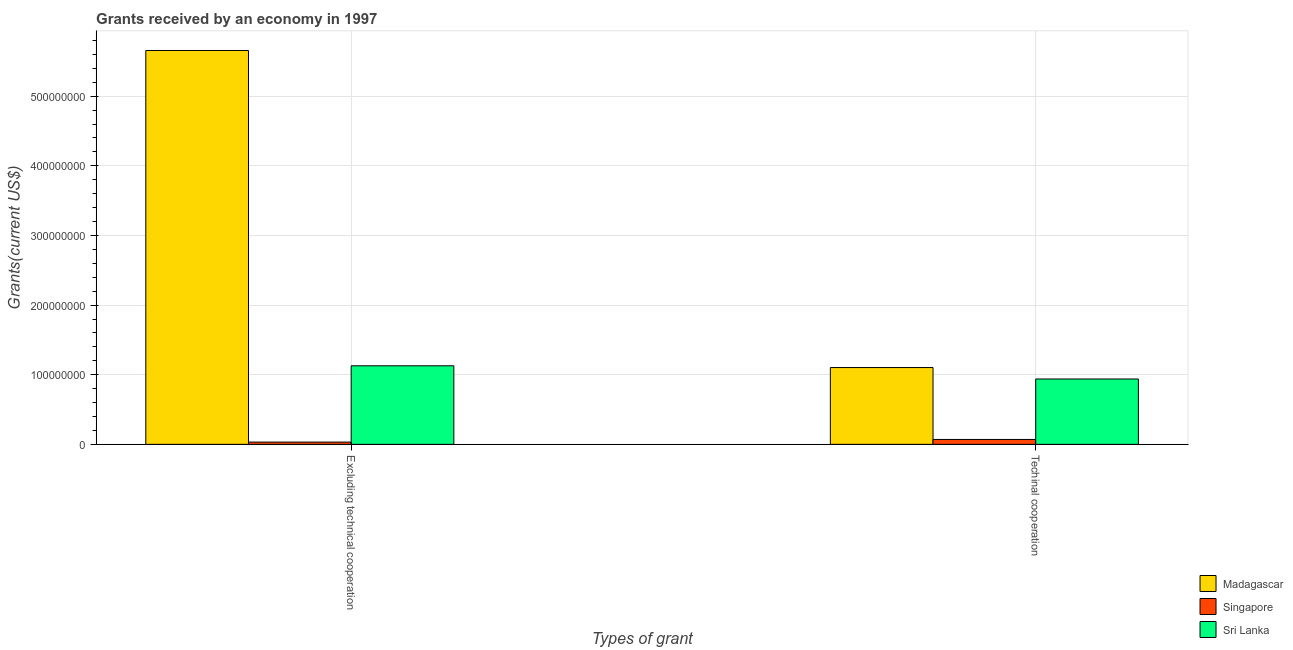Are the number of bars per tick equal to the number of legend labels?
Offer a terse response. Yes. Are the number of bars on each tick of the X-axis equal?
Offer a terse response. Yes. What is the label of the 2nd group of bars from the left?
Provide a succinct answer. Techinal cooperation. What is the amount of grants received(including technical cooperation) in Sri Lanka?
Offer a very short reply. 9.39e+07. Across all countries, what is the maximum amount of grants received(including technical cooperation)?
Your response must be concise. 1.10e+08. Across all countries, what is the minimum amount of grants received(including technical cooperation)?
Offer a terse response. 7.02e+06. In which country was the amount of grants received(excluding technical cooperation) maximum?
Provide a short and direct response. Madagascar. In which country was the amount of grants received(excluding technical cooperation) minimum?
Keep it short and to the point. Singapore. What is the total amount of grants received(including technical cooperation) in the graph?
Provide a succinct answer. 2.11e+08. What is the difference between the amount of grants received(excluding technical cooperation) in Sri Lanka and that in Madagascar?
Your answer should be very brief. -4.53e+08. What is the difference between the amount of grants received(including technical cooperation) in Sri Lanka and the amount of grants received(excluding technical cooperation) in Singapore?
Offer a very short reply. 9.06e+07. What is the average amount of grants received(including technical cooperation) per country?
Make the answer very short. 7.04e+07. What is the difference between the amount of grants received(including technical cooperation) and amount of grants received(excluding technical cooperation) in Sri Lanka?
Provide a succinct answer. -1.90e+07. What is the ratio of the amount of grants received(including technical cooperation) in Madagascar to that in Sri Lanka?
Ensure brevity in your answer.  1.17. Is the amount of grants received(including technical cooperation) in Sri Lanka less than that in Singapore?
Ensure brevity in your answer.  No. What does the 1st bar from the left in Techinal cooperation represents?
Give a very brief answer. Madagascar. What does the 1st bar from the right in Excluding technical cooperation represents?
Provide a succinct answer. Sri Lanka. How many bars are there?
Provide a short and direct response. 6. Are all the bars in the graph horizontal?
Provide a succinct answer. No. Does the graph contain grids?
Your answer should be compact. Yes. What is the title of the graph?
Ensure brevity in your answer.  Grants received by an economy in 1997. What is the label or title of the X-axis?
Provide a succinct answer. Types of grant. What is the label or title of the Y-axis?
Provide a succinct answer. Grants(current US$). What is the Grants(current US$) of Madagascar in Excluding technical cooperation?
Your answer should be compact. 5.66e+08. What is the Grants(current US$) of Singapore in Excluding technical cooperation?
Your response must be concise. 3.26e+06. What is the Grants(current US$) of Sri Lanka in Excluding technical cooperation?
Your answer should be compact. 1.13e+08. What is the Grants(current US$) in Madagascar in Techinal cooperation?
Offer a very short reply. 1.10e+08. What is the Grants(current US$) of Singapore in Techinal cooperation?
Your answer should be very brief. 7.02e+06. What is the Grants(current US$) of Sri Lanka in Techinal cooperation?
Provide a succinct answer. 9.39e+07. Across all Types of grant, what is the maximum Grants(current US$) of Madagascar?
Ensure brevity in your answer.  5.66e+08. Across all Types of grant, what is the maximum Grants(current US$) in Singapore?
Provide a succinct answer. 7.02e+06. Across all Types of grant, what is the maximum Grants(current US$) in Sri Lanka?
Provide a succinct answer. 1.13e+08. Across all Types of grant, what is the minimum Grants(current US$) in Madagascar?
Provide a short and direct response. 1.10e+08. Across all Types of grant, what is the minimum Grants(current US$) in Singapore?
Provide a succinct answer. 3.26e+06. Across all Types of grant, what is the minimum Grants(current US$) in Sri Lanka?
Ensure brevity in your answer.  9.39e+07. What is the total Grants(current US$) of Madagascar in the graph?
Offer a very short reply. 6.76e+08. What is the total Grants(current US$) of Singapore in the graph?
Give a very brief answer. 1.03e+07. What is the total Grants(current US$) in Sri Lanka in the graph?
Keep it short and to the point. 2.07e+08. What is the difference between the Grants(current US$) in Madagascar in Excluding technical cooperation and that in Techinal cooperation?
Offer a terse response. 4.55e+08. What is the difference between the Grants(current US$) of Singapore in Excluding technical cooperation and that in Techinal cooperation?
Your response must be concise. -3.76e+06. What is the difference between the Grants(current US$) of Sri Lanka in Excluding technical cooperation and that in Techinal cooperation?
Give a very brief answer. 1.90e+07. What is the difference between the Grants(current US$) of Madagascar in Excluding technical cooperation and the Grants(current US$) of Singapore in Techinal cooperation?
Offer a terse response. 5.59e+08. What is the difference between the Grants(current US$) in Madagascar in Excluding technical cooperation and the Grants(current US$) in Sri Lanka in Techinal cooperation?
Give a very brief answer. 4.72e+08. What is the difference between the Grants(current US$) in Singapore in Excluding technical cooperation and the Grants(current US$) in Sri Lanka in Techinal cooperation?
Provide a short and direct response. -9.06e+07. What is the average Grants(current US$) of Madagascar per Types of grant?
Provide a short and direct response. 3.38e+08. What is the average Grants(current US$) of Singapore per Types of grant?
Offer a very short reply. 5.14e+06. What is the average Grants(current US$) of Sri Lanka per Types of grant?
Provide a succinct answer. 1.03e+08. What is the difference between the Grants(current US$) in Madagascar and Grants(current US$) in Singapore in Excluding technical cooperation?
Ensure brevity in your answer.  5.62e+08. What is the difference between the Grants(current US$) in Madagascar and Grants(current US$) in Sri Lanka in Excluding technical cooperation?
Your answer should be compact. 4.53e+08. What is the difference between the Grants(current US$) in Singapore and Grants(current US$) in Sri Lanka in Excluding technical cooperation?
Your response must be concise. -1.10e+08. What is the difference between the Grants(current US$) of Madagascar and Grants(current US$) of Singapore in Techinal cooperation?
Provide a succinct answer. 1.03e+08. What is the difference between the Grants(current US$) of Madagascar and Grants(current US$) of Sri Lanka in Techinal cooperation?
Your answer should be compact. 1.64e+07. What is the difference between the Grants(current US$) in Singapore and Grants(current US$) in Sri Lanka in Techinal cooperation?
Give a very brief answer. -8.68e+07. What is the ratio of the Grants(current US$) of Madagascar in Excluding technical cooperation to that in Techinal cooperation?
Your answer should be compact. 5.13. What is the ratio of the Grants(current US$) of Singapore in Excluding technical cooperation to that in Techinal cooperation?
Your answer should be compact. 0.46. What is the ratio of the Grants(current US$) in Sri Lanka in Excluding technical cooperation to that in Techinal cooperation?
Offer a very short reply. 1.2. What is the difference between the highest and the second highest Grants(current US$) in Madagascar?
Your answer should be compact. 4.55e+08. What is the difference between the highest and the second highest Grants(current US$) in Singapore?
Your answer should be compact. 3.76e+06. What is the difference between the highest and the second highest Grants(current US$) of Sri Lanka?
Offer a terse response. 1.90e+07. What is the difference between the highest and the lowest Grants(current US$) in Madagascar?
Offer a terse response. 4.55e+08. What is the difference between the highest and the lowest Grants(current US$) in Singapore?
Keep it short and to the point. 3.76e+06. What is the difference between the highest and the lowest Grants(current US$) of Sri Lanka?
Keep it short and to the point. 1.90e+07. 